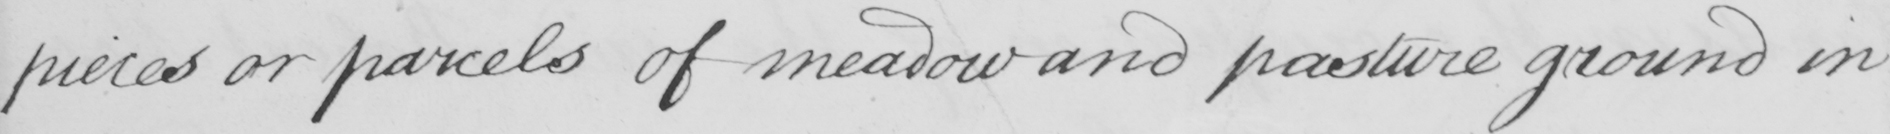What does this handwritten line say? pieces or parcels of meadow and pasture ground in 